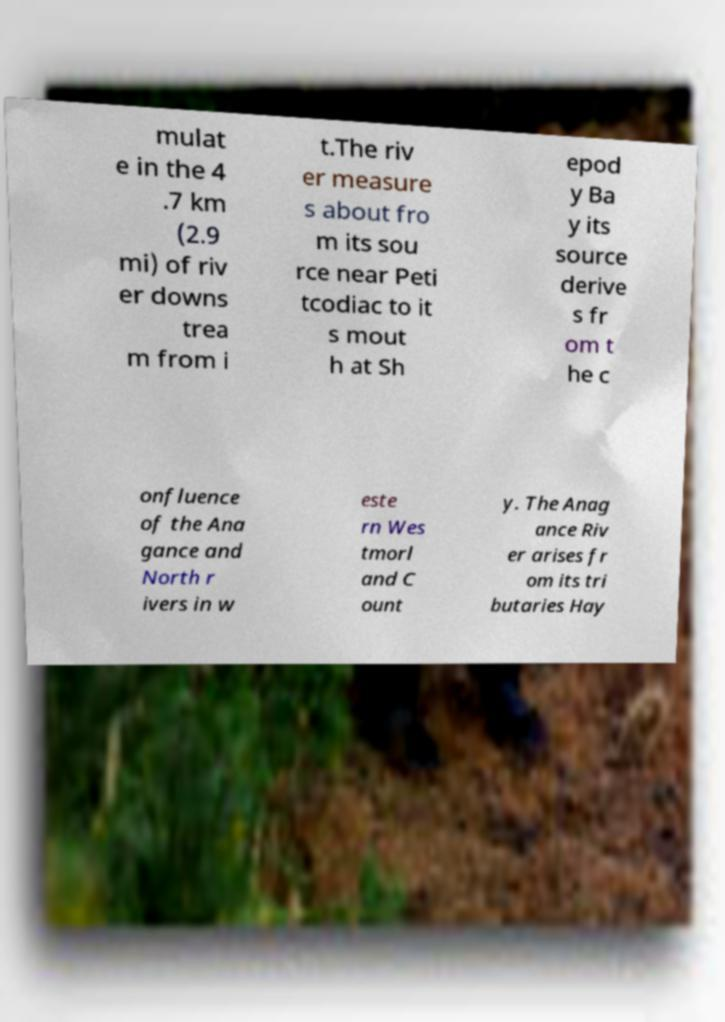I need the written content from this picture converted into text. Can you do that? mulat e in the 4 .7 km (2.9 mi) of riv er downs trea m from i t.The riv er measure s about fro m its sou rce near Peti tcodiac to it s mout h at Sh epod y Ba y its source derive s fr om t he c onfluence of the Ana gance and North r ivers in w este rn Wes tmorl and C ount y. The Anag ance Riv er arises fr om its tri butaries Hay 